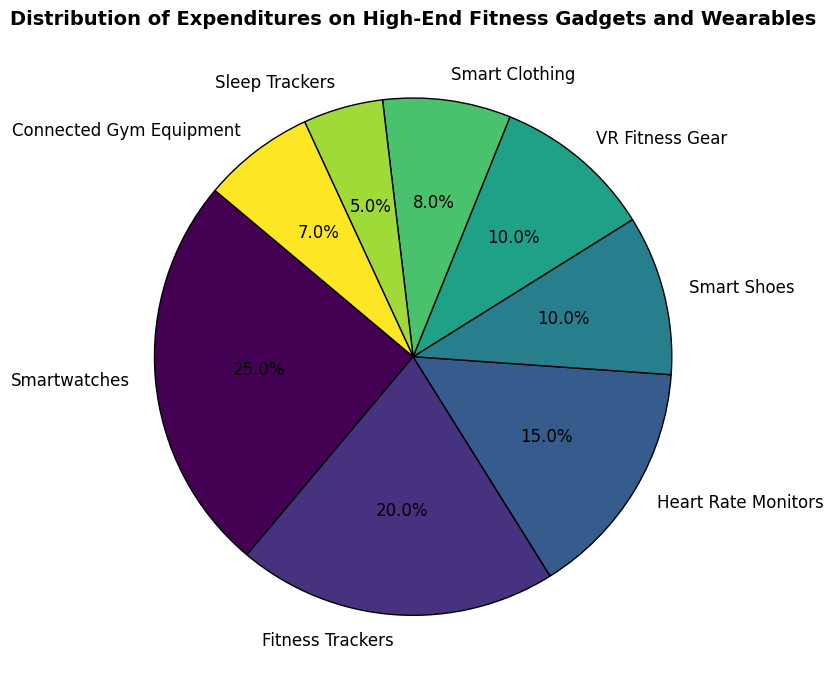What category has the highest expenditure percentage? The slice representing Smartwatches is the largest slice, indicating it has the highest expenditure percentage of 25%.
Answer: Smartwatches Which categories combined account for over 50% of the expenditures? Adding up the percentages for Smartwatches (25%), Fitness Trackers (20%), and Heart Rate Monitors (15%) gives a total of 25 + 20 + 15 = 60%, which is over 50%.
Answer: Smartwatches, Fitness Trackers, and Heart Rate Monitors What is the difference in expenditure percentage between VR Fitness Gear and Smart Clothing? The slice for VR Fitness Gear represents 10%, and the slice for Smart Clothing represents 8%. The difference is 10% - 8% = 2%.
Answer: 2% Are Smart Shoes and VR Fitness Gear allocated an equal percentage of expenditures? The slices for Smart Shoes and VR Fitness Gear are both labeled as 10% each.
Answer: Yes What is the combined expenditure percentage of Smart Shoes and Sleep Trackers? Adding the percentages for Smart Shoes (10%) and Sleep Trackers (5%) gives a total of 10 + 5 = 15%.
Answer: 15% Which categories have a smaller expenditure percentage than Smart Shoes? The categories with smaller percentages than Smart Shoes (10%) are Smart Clothing (8%), Sleep Trackers (5%), and Connected Gym Equipment (7%).
Answer: Smart Clothing, Sleep Trackers, and Connected Gym Equipment How much more is spent on Fitness Trackers compared to Connected Gym Equipment? The expenditure for Fitness Trackers is 20%, and for Connected Gym Equipment it is 7%. The difference is 20% - 7% = 13%.
Answer: 13% Which category has the smallest expenditure percentage? The slice representing Sleep Trackers is the smallest slice, indicating it has the lowest expenditure percentage of 5%.
Answer: Sleep Trackers Is the total expenditure on Smartwatches and Fitness Trackers greater than the sum of expenditures on Smart Shoes, VR Fitness Gear, and Smart Clothing? Adding the percentages for Smartwatches (25%) and Fitness Trackers (20%) gives a total of 25 + 20 = 45%. Adding the percentages for Smart Shoes (10%), VR Fitness Gear (10%), and Smart Clothing (8%) gives a total of 10 + 10 + 8 = 28%. Since 45% is greater than 28%, the total expenditure on Smartwatches and Fitness Trackers is indeed greater.
Answer: Yes How many categories have an expenditure percentage of 10% or more? The categories with 10% or more expenditure percentages are Smartwatches (25%), Fitness Trackers (20%), Heart Rate Monitors (15%), Smart Shoes (10%), and VR Fitness Gear (10%). This counts as 5 categories.
Answer: 5 